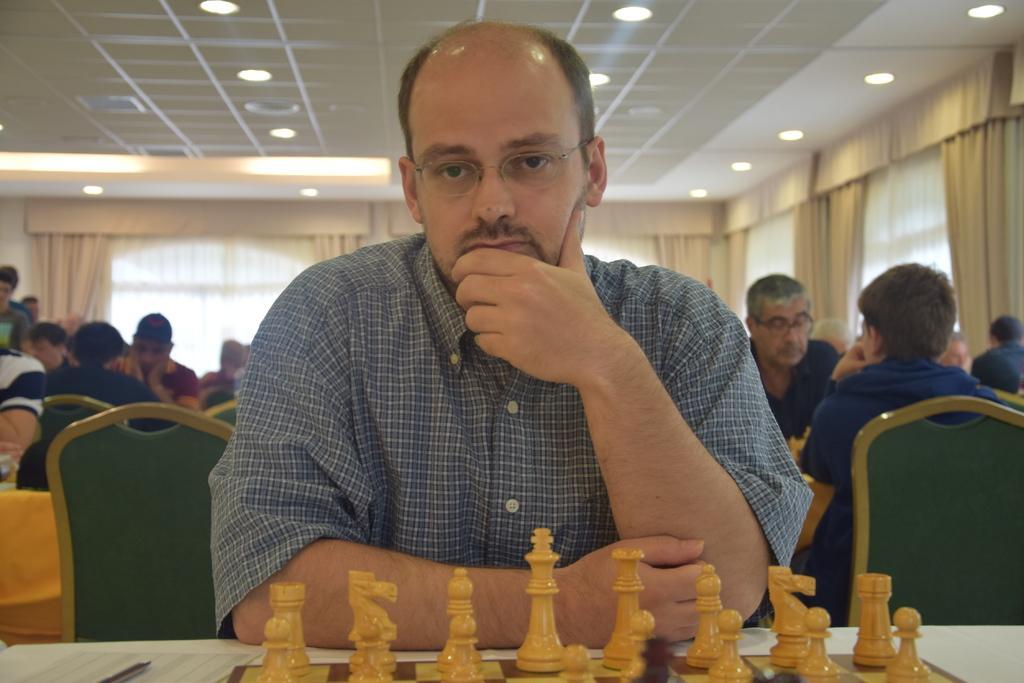Could you give a brief overview of what you see in this image? In the center of the image we can see one person sitting. In front of him, there is a table. On the table, we can see one chess board, etc. In the background there is a wall, curtains, lights, few people are sitting on the chairs and a few other objects. 